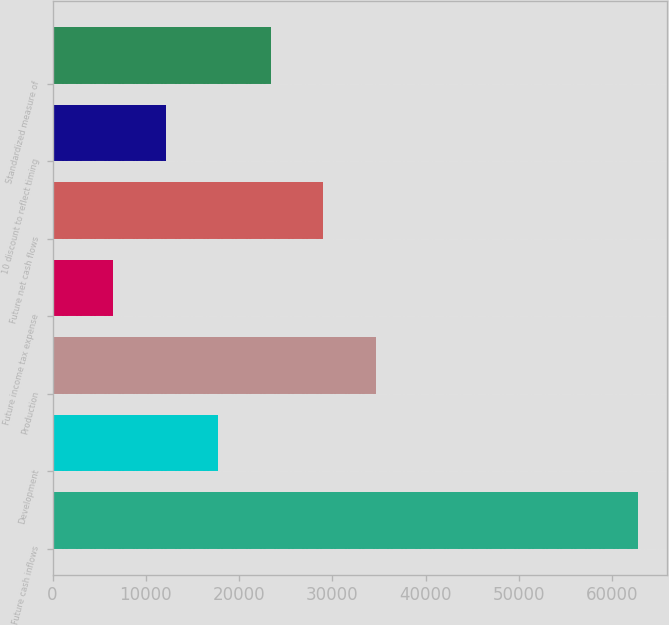Convert chart. <chart><loc_0><loc_0><loc_500><loc_500><bar_chart><fcel>Future cash inflows<fcel>Development<fcel>Production<fcel>Future income tax expense<fcel>Future net cash flows<fcel>10 discount to reflect timing<fcel>Standardized measure of<nl><fcel>62743<fcel>17770.2<fcel>34635<fcel>6527<fcel>29013.4<fcel>12148.6<fcel>23391.8<nl></chart> 